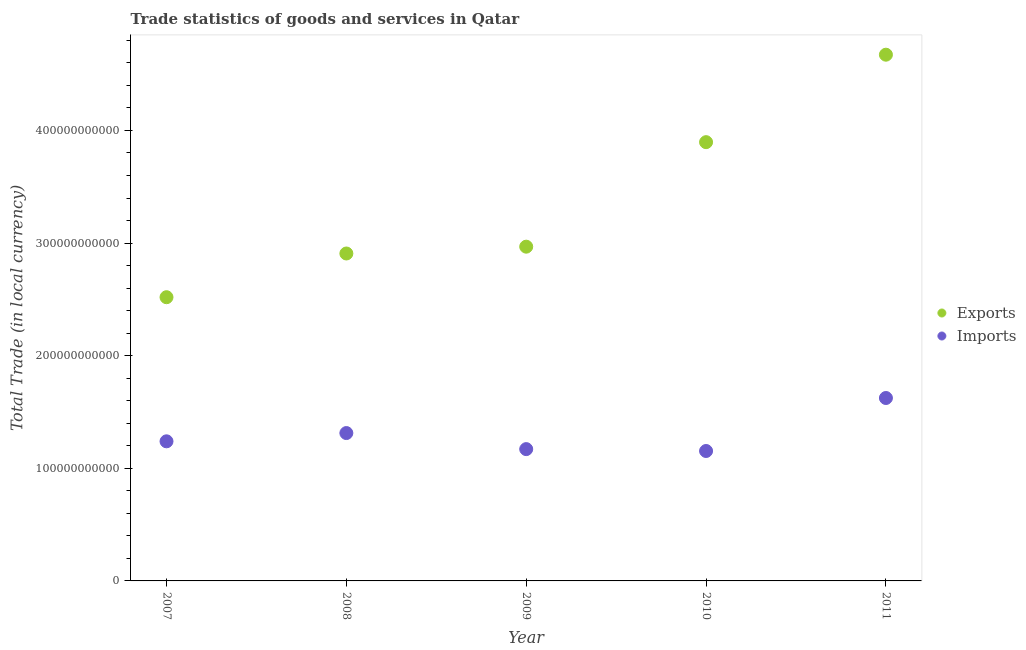How many different coloured dotlines are there?
Provide a short and direct response. 2. Is the number of dotlines equal to the number of legend labels?
Your response must be concise. Yes. What is the export of goods and services in 2011?
Make the answer very short. 4.67e+11. Across all years, what is the maximum imports of goods and services?
Your answer should be very brief. 1.62e+11. Across all years, what is the minimum export of goods and services?
Offer a terse response. 2.52e+11. In which year was the imports of goods and services maximum?
Offer a very short reply. 2011. In which year was the imports of goods and services minimum?
Your answer should be compact. 2010. What is the total imports of goods and services in the graph?
Offer a very short reply. 6.50e+11. What is the difference between the imports of goods and services in 2009 and that in 2010?
Provide a succinct answer. 1.67e+09. What is the difference between the export of goods and services in 2009 and the imports of goods and services in 2008?
Your response must be concise. 1.66e+11. What is the average imports of goods and services per year?
Provide a succinct answer. 1.30e+11. In the year 2010, what is the difference between the export of goods and services and imports of goods and services?
Your answer should be compact. 2.74e+11. In how many years, is the export of goods and services greater than 400000000000 LCU?
Keep it short and to the point. 1. What is the ratio of the imports of goods and services in 2008 to that in 2009?
Provide a short and direct response. 1.12. Is the export of goods and services in 2007 less than that in 2008?
Offer a terse response. Yes. What is the difference between the highest and the second highest imports of goods and services?
Your answer should be compact. 3.11e+1. What is the difference between the highest and the lowest imports of goods and services?
Your response must be concise. 4.71e+1. In how many years, is the export of goods and services greater than the average export of goods and services taken over all years?
Keep it short and to the point. 2. Is the export of goods and services strictly less than the imports of goods and services over the years?
Give a very brief answer. No. How many dotlines are there?
Give a very brief answer. 2. How many years are there in the graph?
Your answer should be compact. 5. What is the difference between two consecutive major ticks on the Y-axis?
Provide a short and direct response. 1.00e+11. Are the values on the major ticks of Y-axis written in scientific E-notation?
Offer a terse response. No. Does the graph contain any zero values?
Ensure brevity in your answer.  No. Does the graph contain grids?
Provide a succinct answer. No. What is the title of the graph?
Give a very brief answer. Trade statistics of goods and services in Qatar. Does "External balance on goods" appear as one of the legend labels in the graph?
Provide a succinct answer. No. What is the label or title of the Y-axis?
Offer a terse response. Total Trade (in local currency). What is the Total Trade (in local currency) in Exports in 2007?
Provide a succinct answer. 2.52e+11. What is the Total Trade (in local currency) in Imports in 2007?
Your response must be concise. 1.24e+11. What is the Total Trade (in local currency) in Exports in 2008?
Keep it short and to the point. 2.91e+11. What is the Total Trade (in local currency) in Imports in 2008?
Ensure brevity in your answer.  1.31e+11. What is the Total Trade (in local currency) of Exports in 2009?
Provide a succinct answer. 2.97e+11. What is the Total Trade (in local currency) of Imports in 2009?
Make the answer very short. 1.17e+11. What is the Total Trade (in local currency) of Exports in 2010?
Give a very brief answer. 3.90e+11. What is the Total Trade (in local currency) in Imports in 2010?
Your answer should be compact. 1.15e+11. What is the Total Trade (in local currency) in Exports in 2011?
Your answer should be very brief. 4.67e+11. What is the Total Trade (in local currency) in Imports in 2011?
Provide a succinct answer. 1.62e+11. Across all years, what is the maximum Total Trade (in local currency) in Exports?
Your response must be concise. 4.67e+11. Across all years, what is the maximum Total Trade (in local currency) in Imports?
Provide a succinct answer. 1.62e+11. Across all years, what is the minimum Total Trade (in local currency) of Exports?
Your response must be concise. 2.52e+11. Across all years, what is the minimum Total Trade (in local currency) in Imports?
Offer a terse response. 1.15e+11. What is the total Total Trade (in local currency) in Exports in the graph?
Keep it short and to the point. 1.70e+12. What is the total Total Trade (in local currency) in Imports in the graph?
Ensure brevity in your answer.  6.50e+11. What is the difference between the Total Trade (in local currency) of Exports in 2007 and that in 2008?
Provide a short and direct response. -3.88e+1. What is the difference between the Total Trade (in local currency) in Imports in 2007 and that in 2008?
Ensure brevity in your answer.  -7.34e+09. What is the difference between the Total Trade (in local currency) of Exports in 2007 and that in 2009?
Provide a short and direct response. -4.49e+1. What is the difference between the Total Trade (in local currency) in Imports in 2007 and that in 2009?
Your response must be concise. 6.93e+09. What is the difference between the Total Trade (in local currency) in Exports in 2007 and that in 2010?
Give a very brief answer. -1.38e+11. What is the difference between the Total Trade (in local currency) in Imports in 2007 and that in 2010?
Your response must be concise. 8.60e+09. What is the difference between the Total Trade (in local currency) in Exports in 2007 and that in 2011?
Provide a succinct answer. -2.15e+11. What is the difference between the Total Trade (in local currency) of Imports in 2007 and that in 2011?
Your answer should be very brief. -3.85e+1. What is the difference between the Total Trade (in local currency) in Exports in 2008 and that in 2009?
Offer a terse response. -6.06e+09. What is the difference between the Total Trade (in local currency) in Imports in 2008 and that in 2009?
Ensure brevity in your answer.  1.43e+1. What is the difference between the Total Trade (in local currency) of Exports in 2008 and that in 2010?
Offer a terse response. -9.89e+1. What is the difference between the Total Trade (in local currency) of Imports in 2008 and that in 2010?
Make the answer very short. 1.59e+1. What is the difference between the Total Trade (in local currency) of Exports in 2008 and that in 2011?
Offer a terse response. -1.77e+11. What is the difference between the Total Trade (in local currency) in Imports in 2008 and that in 2011?
Your answer should be compact. -3.11e+1. What is the difference between the Total Trade (in local currency) of Exports in 2009 and that in 2010?
Provide a short and direct response. -9.28e+1. What is the difference between the Total Trade (in local currency) in Imports in 2009 and that in 2010?
Your response must be concise. 1.67e+09. What is the difference between the Total Trade (in local currency) in Exports in 2009 and that in 2011?
Offer a very short reply. -1.70e+11. What is the difference between the Total Trade (in local currency) of Imports in 2009 and that in 2011?
Offer a terse response. -4.54e+1. What is the difference between the Total Trade (in local currency) of Exports in 2010 and that in 2011?
Your answer should be very brief. -7.77e+1. What is the difference between the Total Trade (in local currency) in Imports in 2010 and that in 2011?
Provide a succinct answer. -4.71e+1. What is the difference between the Total Trade (in local currency) of Exports in 2007 and the Total Trade (in local currency) of Imports in 2008?
Your answer should be compact. 1.21e+11. What is the difference between the Total Trade (in local currency) in Exports in 2007 and the Total Trade (in local currency) in Imports in 2009?
Provide a succinct answer. 1.35e+11. What is the difference between the Total Trade (in local currency) in Exports in 2007 and the Total Trade (in local currency) in Imports in 2010?
Keep it short and to the point. 1.37e+11. What is the difference between the Total Trade (in local currency) in Exports in 2007 and the Total Trade (in local currency) in Imports in 2011?
Give a very brief answer. 8.95e+1. What is the difference between the Total Trade (in local currency) in Exports in 2008 and the Total Trade (in local currency) in Imports in 2009?
Keep it short and to the point. 1.74e+11. What is the difference between the Total Trade (in local currency) of Exports in 2008 and the Total Trade (in local currency) of Imports in 2010?
Your answer should be compact. 1.75e+11. What is the difference between the Total Trade (in local currency) in Exports in 2008 and the Total Trade (in local currency) in Imports in 2011?
Ensure brevity in your answer.  1.28e+11. What is the difference between the Total Trade (in local currency) of Exports in 2009 and the Total Trade (in local currency) of Imports in 2010?
Offer a terse response. 1.81e+11. What is the difference between the Total Trade (in local currency) in Exports in 2009 and the Total Trade (in local currency) in Imports in 2011?
Your answer should be very brief. 1.34e+11. What is the difference between the Total Trade (in local currency) of Exports in 2010 and the Total Trade (in local currency) of Imports in 2011?
Your answer should be compact. 2.27e+11. What is the average Total Trade (in local currency) of Exports per year?
Your answer should be very brief. 3.39e+11. What is the average Total Trade (in local currency) of Imports per year?
Provide a succinct answer. 1.30e+11. In the year 2007, what is the difference between the Total Trade (in local currency) of Exports and Total Trade (in local currency) of Imports?
Give a very brief answer. 1.28e+11. In the year 2008, what is the difference between the Total Trade (in local currency) in Exports and Total Trade (in local currency) in Imports?
Provide a succinct answer. 1.59e+11. In the year 2009, what is the difference between the Total Trade (in local currency) in Exports and Total Trade (in local currency) in Imports?
Keep it short and to the point. 1.80e+11. In the year 2010, what is the difference between the Total Trade (in local currency) in Exports and Total Trade (in local currency) in Imports?
Your answer should be very brief. 2.74e+11. In the year 2011, what is the difference between the Total Trade (in local currency) in Exports and Total Trade (in local currency) in Imports?
Your answer should be compact. 3.05e+11. What is the ratio of the Total Trade (in local currency) of Exports in 2007 to that in 2008?
Your answer should be compact. 0.87. What is the ratio of the Total Trade (in local currency) in Imports in 2007 to that in 2008?
Your response must be concise. 0.94. What is the ratio of the Total Trade (in local currency) of Exports in 2007 to that in 2009?
Provide a succinct answer. 0.85. What is the ratio of the Total Trade (in local currency) of Imports in 2007 to that in 2009?
Keep it short and to the point. 1.06. What is the ratio of the Total Trade (in local currency) in Exports in 2007 to that in 2010?
Keep it short and to the point. 0.65. What is the ratio of the Total Trade (in local currency) of Imports in 2007 to that in 2010?
Your answer should be very brief. 1.07. What is the ratio of the Total Trade (in local currency) in Exports in 2007 to that in 2011?
Your response must be concise. 0.54. What is the ratio of the Total Trade (in local currency) in Imports in 2007 to that in 2011?
Ensure brevity in your answer.  0.76. What is the ratio of the Total Trade (in local currency) in Exports in 2008 to that in 2009?
Keep it short and to the point. 0.98. What is the ratio of the Total Trade (in local currency) in Imports in 2008 to that in 2009?
Offer a terse response. 1.12. What is the ratio of the Total Trade (in local currency) in Exports in 2008 to that in 2010?
Offer a very short reply. 0.75. What is the ratio of the Total Trade (in local currency) of Imports in 2008 to that in 2010?
Provide a succinct answer. 1.14. What is the ratio of the Total Trade (in local currency) of Exports in 2008 to that in 2011?
Give a very brief answer. 0.62. What is the ratio of the Total Trade (in local currency) in Imports in 2008 to that in 2011?
Offer a terse response. 0.81. What is the ratio of the Total Trade (in local currency) of Exports in 2009 to that in 2010?
Provide a succinct answer. 0.76. What is the ratio of the Total Trade (in local currency) of Imports in 2009 to that in 2010?
Provide a short and direct response. 1.01. What is the ratio of the Total Trade (in local currency) in Exports in 2009 to that in 2011?
Your answer should be compact. 0.64. What is the ratio of the Total Trade (in local currency) in Imports in 2009 to that in 2011?
Make the answer very short. 0.72. What is the ratio of the Total Trade (in local currency) in Exports in 2010 to that in 2011?
Provide a succinct answer. 0.83. What is the ratio of the Total Trade (in local currency) in Imports in 2010 to that in 2011?
Give a very brief answer. 0.71. What is the difference between the highest and the second highest Total Trade (in local currency) of Exports?
Your answer should be compact. 7.77e+1. What is the difference between the highest and the second highest Total Trade (in local currency) in Imports?
Provide a succinct answer. 3.11e+1. What is the difference between the highest and the lowest Total Trade (in local currency) in Exports?
Offer a terse response. 2.15e+11. What is the difference between the highest and the lowest Total Trade (in local currency) of Imports?
Your answer should be very brief. 4.71e+1. 